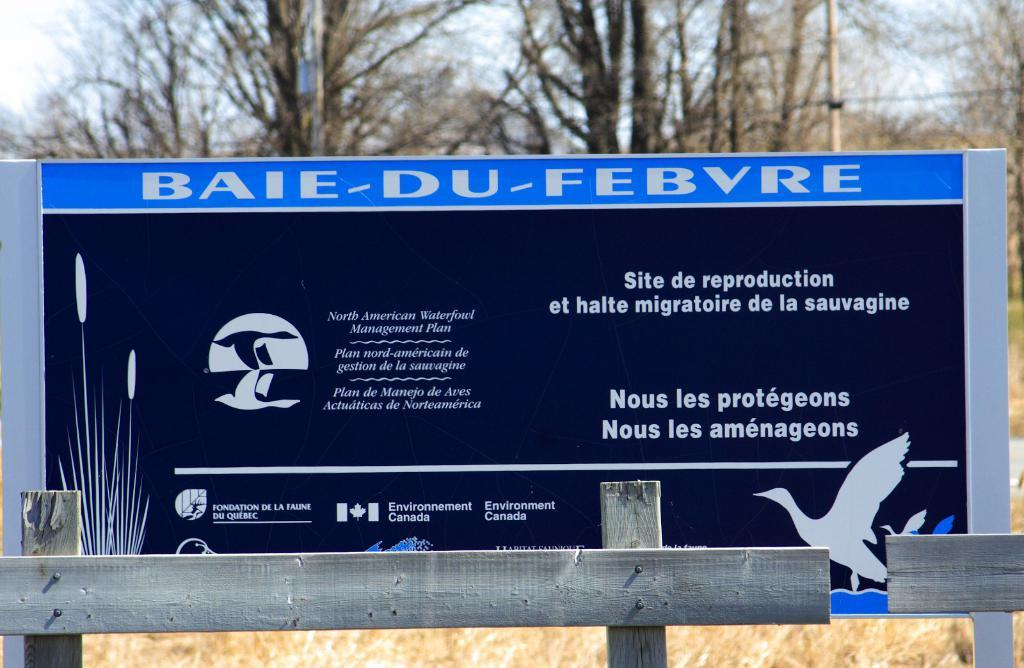<image>
Relay a brief, clear account of the picture shown. A sign near a wetland for migratory birds provided by Environment Canada. 